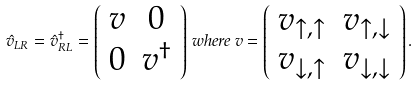Convert formula to latex. <formula><loc_0><loc_0><loc_500><loc_500>\hat { v } _ { L R } = \hat { v } ^ { \dagger } _ { R L } = \left ( \begin{array} { c c } v & 0 \\ 0 & v ^ { \dagger } \end{array} \right ) \, w h e r e \, v = \left ( \begin{array} { c c } v _ { \uparrow , \uparrow } & v _ { \uparrow , \downarrow } \\ v _ { \downarrow , \uparrow } & v _ { \downarrow , \downarrow } \end{array} \right ) .</formula> 